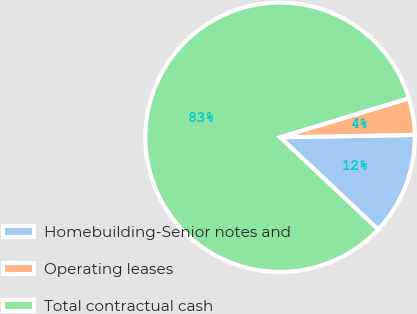Convert chart. <chart><loc_0><loc_0><loc_500><loc_500><pie_chart><fcel>Homebuilding-Senior notes and<fcel>Operating leases<fcel>Total contractual cash<nl><fcel>12.29%<fcel>4.4%<fcel>83.32%<nl></chart> 